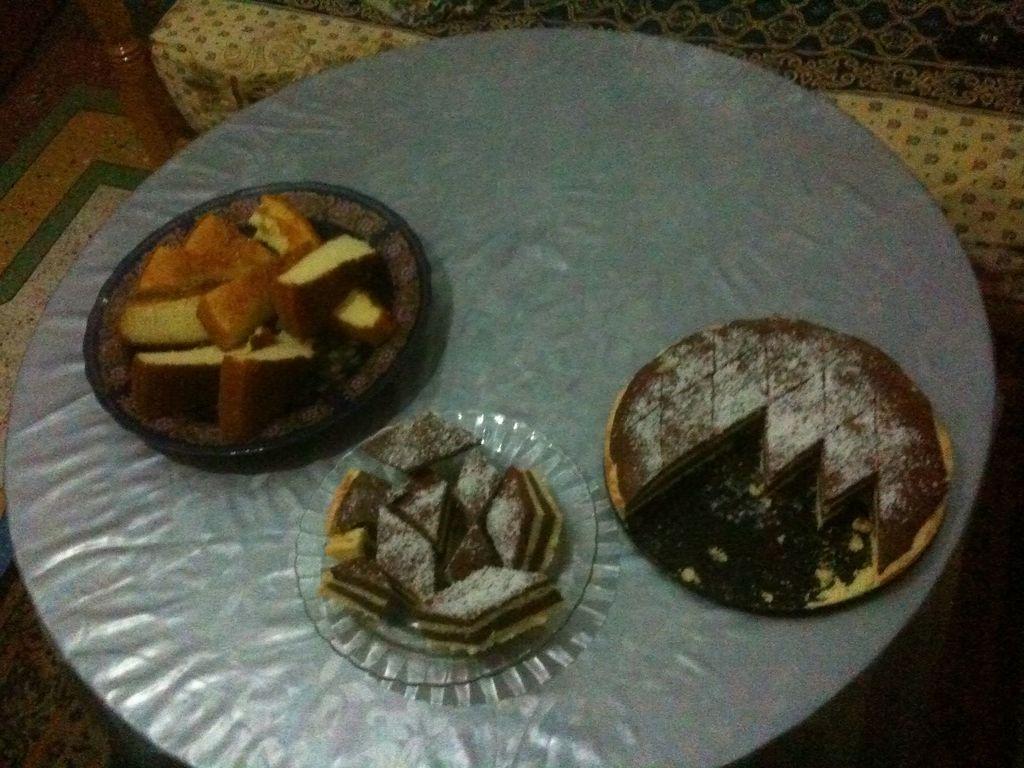How would you summarize this image in a sentence or two? Here in this picture we can see a table on which we can see plates with full of sweets and cake pieces present and beside that we can see a sofa present. 